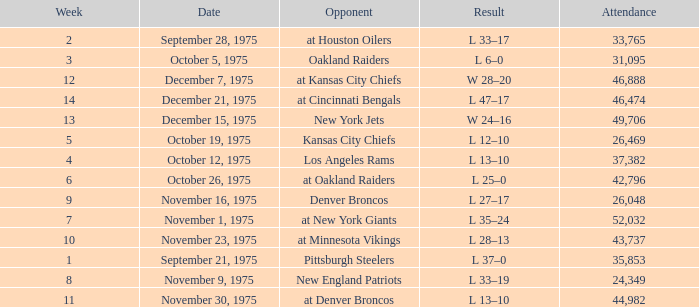Could you parse the entire table as a dict? {'header': ['Week', 'Date', 'Opponent', 'Result', 'Attendance'], 'rows': [['2', 'September 28, 1975', 'at Houston Oilers', 'L 33–17', '33,765'], ['3', 'October 5, 1975', 'Oakland Raiders', 'L 6–0', '31,095'], ['12', 'December 7, 1975', 'at Kansas City Chiefs', 'W 28–20', '46,888'], ['14', 'December 21, 1975', 'at Cincinnati Bengals', 'L 47–17', '46,474'], ['13', 'December 15, 1975', 'New York Jets', 'W 24–16', '49,706'], ['5', 'October 19, 1975', 'Kansas City Chiefs', 'L 12–10', '26,469'], ['4', 'October 12, 1975', 'Los Angeles Rams', 'L 13–10', '37,382'], ['6', 'October 26, 1975', 'at Oakland Raiders', 'L 25–0', '42,796'], ['9', 'November 16, 1975', 'Denver Broncos', 'L 27–17', '26,048'], ['7', 'November 1, 1975', 'at New York Giants', 'L 35–24', '52,032'], ['10', 'November 23, 1975', 'at Minnesota Vikings', 'L 28–13', '43,737'], ['1', 'September 21, 1975', 'Pittsburgh Steelers', 'L 37–0', '35,853'], ['8', 'November 9, 1975', 'New England Patriots', 'L 33–19', '24,349'], ['11', 'November 30, 1975', 'at Denver Broncos', 'L 13–10', '44,982']]} What is the lowest Week when the result was l 13–10, November 30, 1975, with more than 44,982 people in attendance? None. 